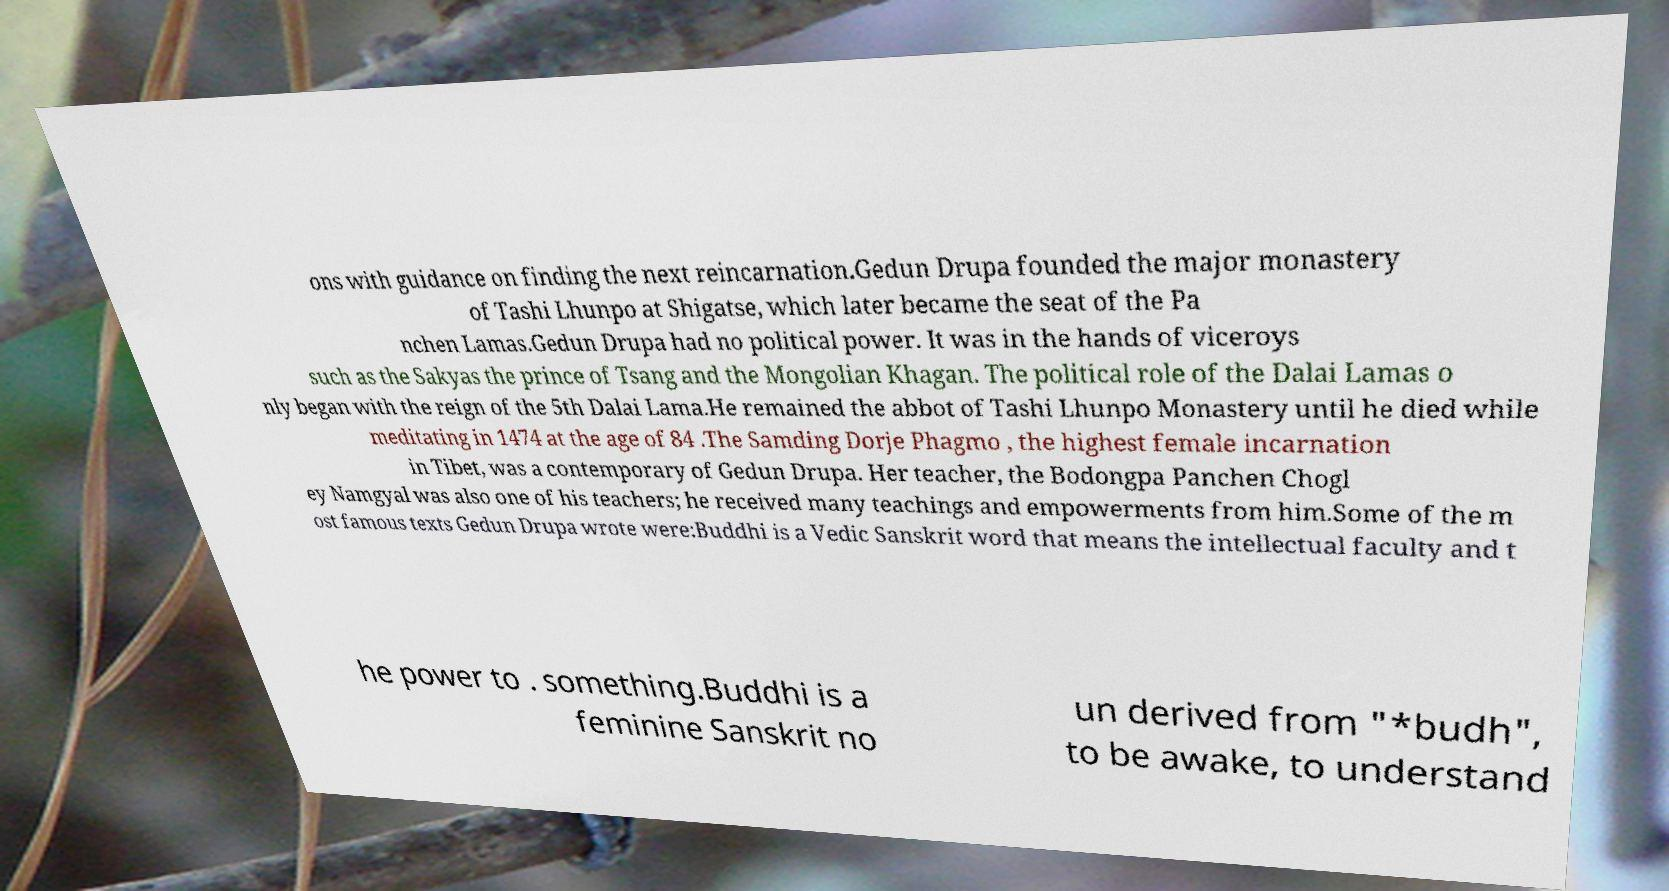There's text embedded in this image that I need extracted. Can you transcribe it verbatim? ons with guidance on finding the next reincarnation.Gedun Drupa founded the major monastery of Tashi Lhunpo at Shigatse, which later became the seat of the Pa nchen Lamas.Gedun Drupa had no political power. It was in the hands of viceroys such as the Sakyas the prince of Tsang and the Mongolian Khagan. The political role of the Dalai Lamas o nly began with the reign of the 5th Dalai Lama.He remained the abbot of Tashi Lhunpo Monastery until he died while meditating in 1474 at the age of 84 .The Samding Dorje Phagmo , the highest female incarnation in Tibet, was a contemporary of Gedun Drupa. Her teacher, the Bodongpa Panchen Chogl ey Namgyal was also one of his teachers; he received many teachings and empowerments from him.Some of the m ost famous texts Gedun Drupa wrote were:Buddhi is a Vedic Sanskrit word that means the intellectual faculty and t he power to . something.Buddhi is a feminine Sanskrit no un derived from "*budh", to be awake, to understand 